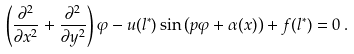<formula> <loc_0><loc_0><loc_500><loc_500>\left ( \frac { \partial ^ { 2 } } { \partial x ^ { 2 } } + \frac { \partial ^ { 2 } } { \partial y ^ { 2 } } \right ) \varphi - u ( l ^ { \ast } ) \sin \left ( p \varphi + \alpha ( x ) \right ) + f ( l ^ { \ast } ) = 0 \, .</formula> 